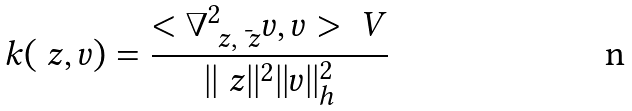Convert formula to latex. <formula><loc_0><loc_0><loc_500><loc_500>k ( \ z , v ) = \frac { < \nabla ^ { 2 } _ { \ z , \bar { \ z } } v , v > _ { \ } V } { | | \ z | | ^ { 2 } | | v | | ^ { 2 } _ { h } }</formula> 